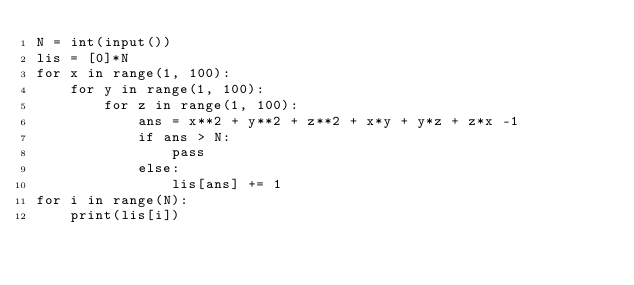Convert code to text. <code><loc_0><loc_0><loc_500><loc_500><_Python_>N = int(input())
lis = [0]*N
for x in range(1, 100):
    for y in range(1, 100):
        for z in range(1, 100):
            ans = x**2 + y**2 + z**2 + x*y + y*z + z*x -1
            if ans > N:
                pass
            else:
                lis[ans] += 1
for i in range(N):
    print(lis[i])</code> 